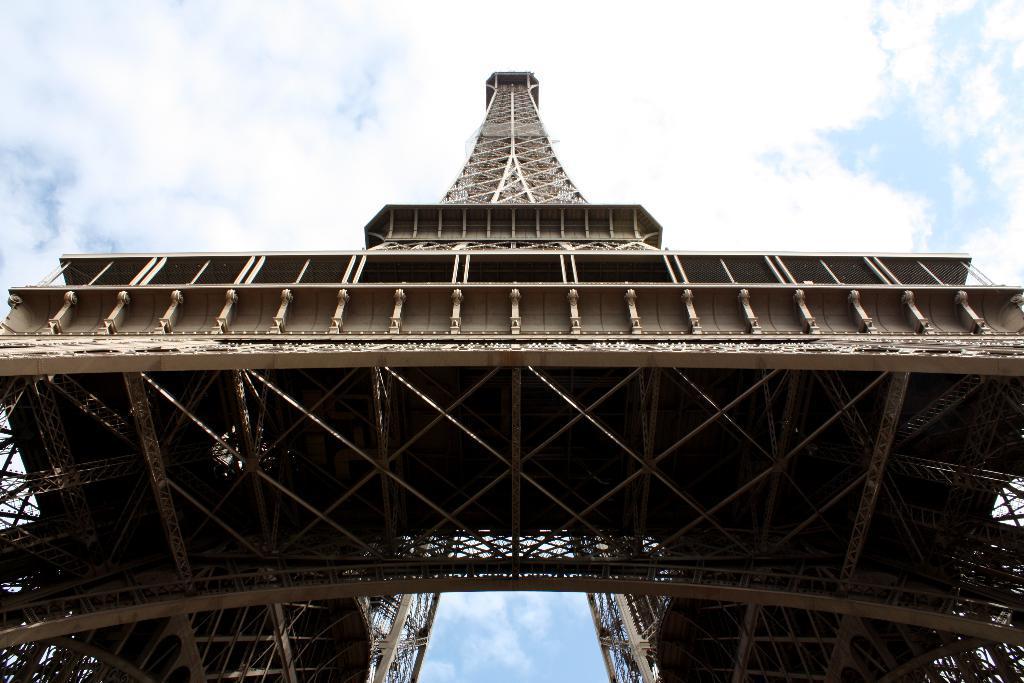What famous landmark can be seen in the image? The Eiffel Tower is present in the image. What is visible in the sky at the top of the image? There are clouds in the sky at the top of the image. What type of rock can be seen in the image? There is no rock present in the image; it features the Eiffel Tower and clouds in the sky. How does the brain appear in the image? There is no brain present in the image; it only shows the Eiffel Tower and clouds in the sky. 